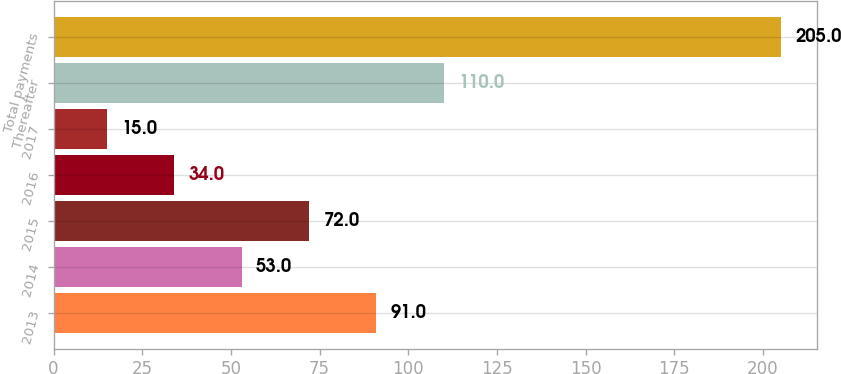Convert chart to OTSL. <chart><loc_0><loc_0><loc_500><loc_500><bar_chart><fcel>2013<fcel>2014<fcel>2015<fcel>2016<fcel>2017<fcel>Thereafter<fcel>Total payments<nl><fcel>91<fcel>53<fcel>72<fcel>34<fcel>15<fcel>110<fcel>205<nl></chart> 